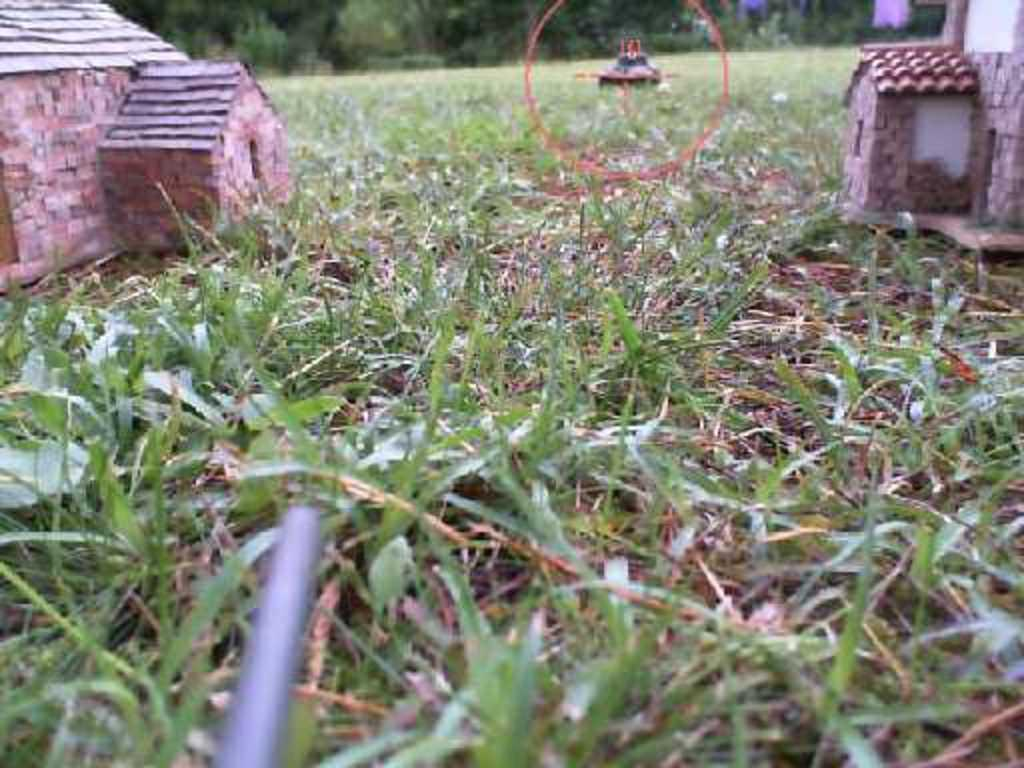What type of structures are present in the image? There are small houses made from cotton or other objects in the image. What is visible at the bottom of the image? Grass is visible at the bottom of the image. What can be seen in the background of the image? There are many trees and a building in the background of the image. What color is the crayon used to draw the wrench in the image? There is no crayon or wrench present in the image. 